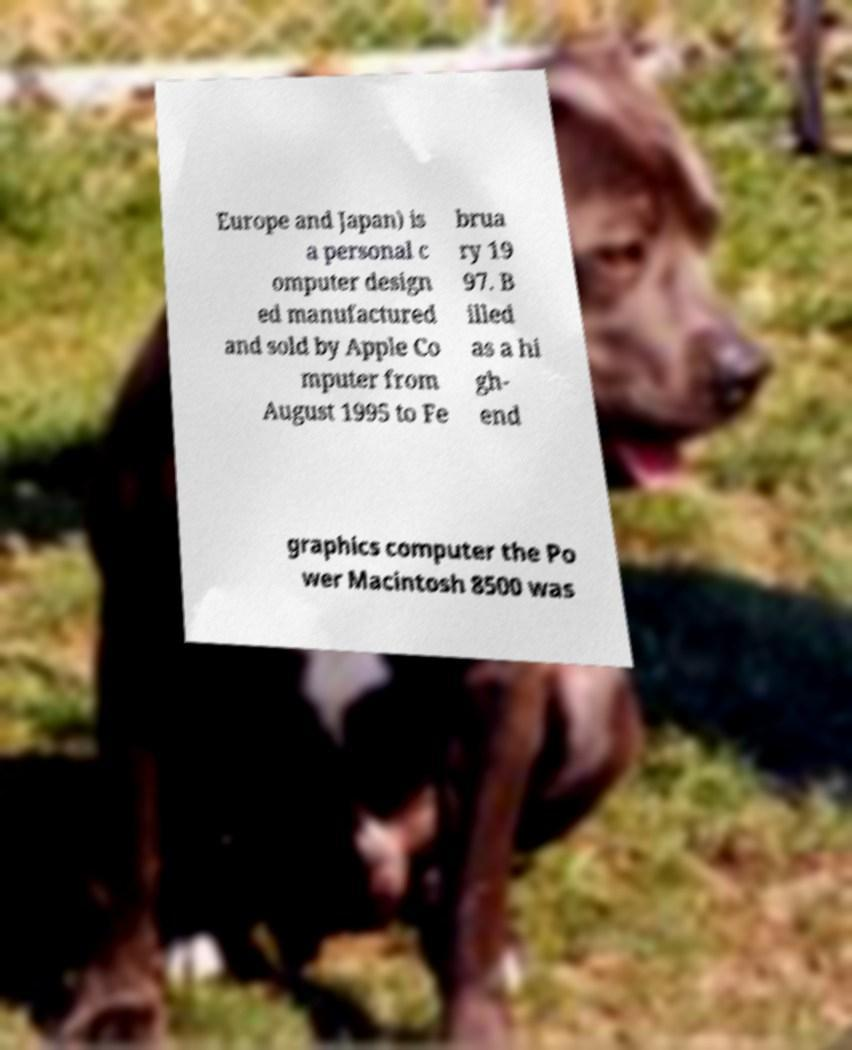Please identify and transcribe the text found in this image. Europe and Japan) is a personal c omputer design ed manufactured and sold by Apple Co mputer from August 1995 to Fe brua ry 19 97. B illed as a hi gh- end graphics computer the Po wer Macintosh 8500 was 